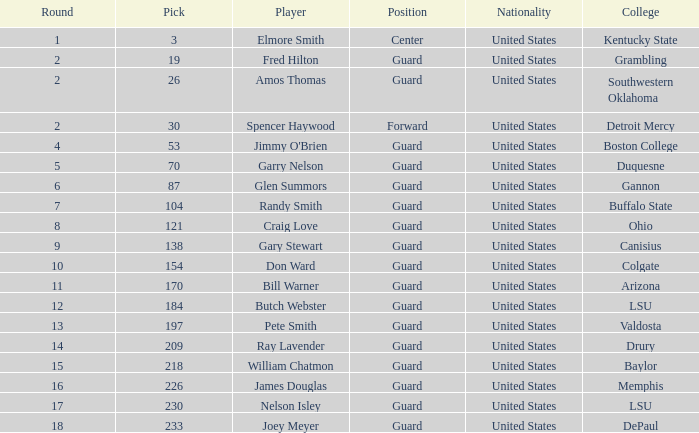What rotation has a sentinel spot at ohio university? 8.0. 